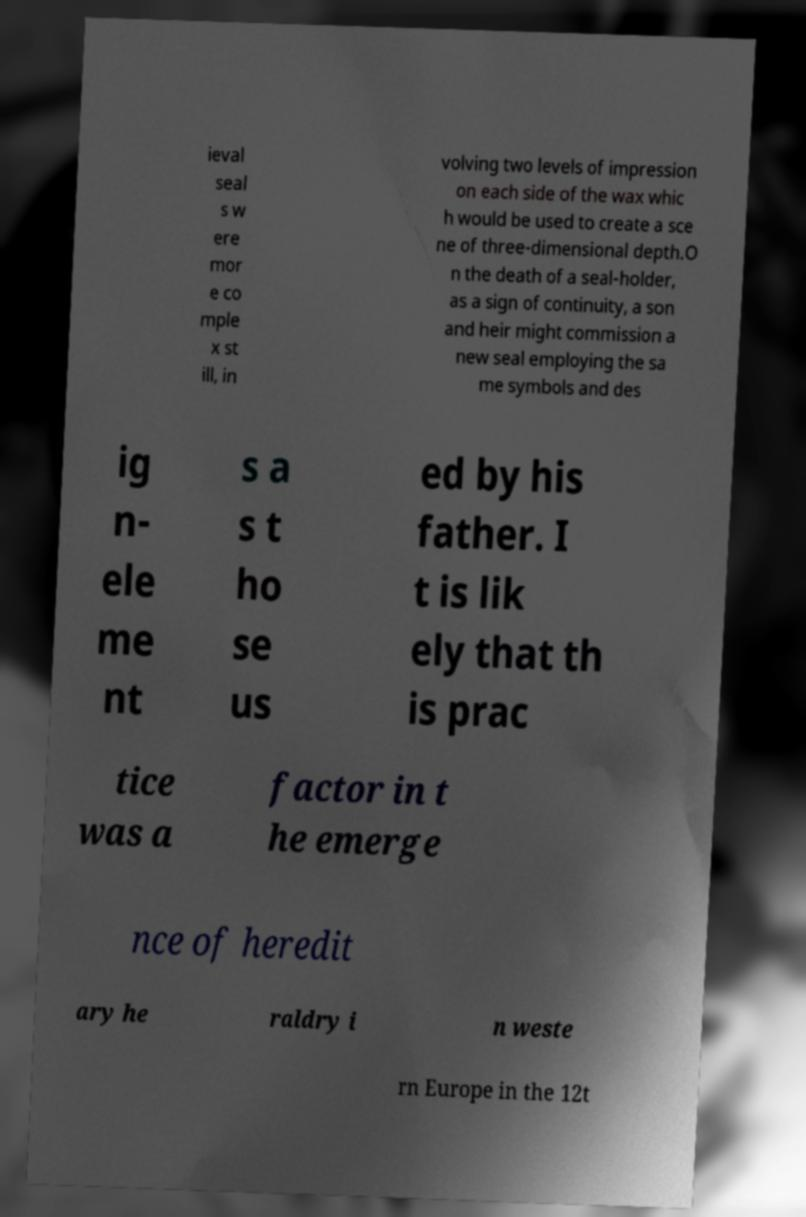I need the written content from this picture converted into text. Can you do that? ieval seal s w ere mor e co mple x st ill, in volving two levels of impression on each side of the wax whic h would be used to create a sce ne of three-dimensional depth.O n the death of a seal-holder, as a sign of continuity, a son and heir might commission a new seal employing the sa me symbols and des ig n- ele me nt s a s t ho se us ed by his father. I t is lik ely that th is prac tice was a factor in t he emerge nce of heredit ary he raldry i n weste rn Europe in the 12t 